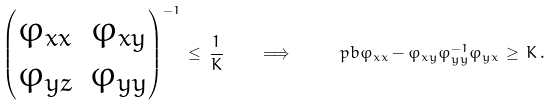Convert formula to latex. <formula><loc_0><loc_0><loc_500><loc_500>\begin{pmatrix} \varphi _ { x x } & \varphi _ { x y } \\ \varphi _ { y z } & \varphi _ { y y } \end{pmatrix} ^ { - 1 } \, \leq \, \frac { 1 } { K } \quad \Longrightarrow \quad \ p b { \varphi _ { x x } - \varphi _ { x y } \varphi _ { y y } ^ { - 1 } \varphi _ { y x } } \, \geq \, K \, .</formula> 